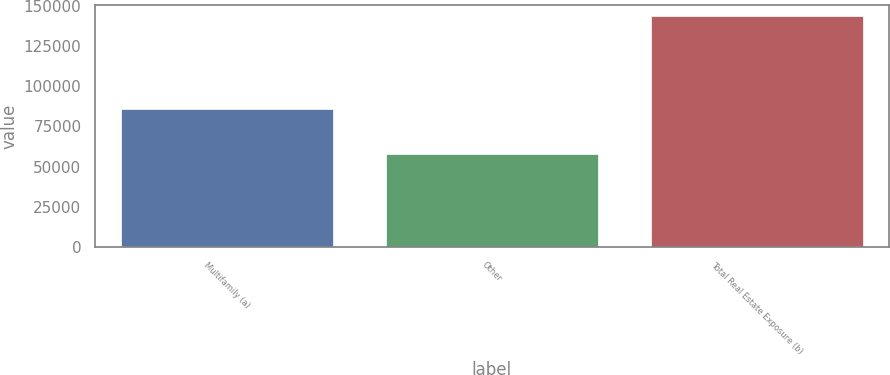Convert chart. <chart><loc_0><loc_0><loc_500><loc_500><bar_chart><fcel>Multifamily (a)<fcel>Other<fcel>Total Real Estate Exposure (b)<nl><fcel>85716<fcel>57600<fcel>143316<nl></chart> 